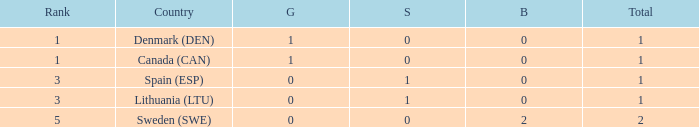How many bronze medals were won when the total is more than 1, and gold is more than 0? None. 